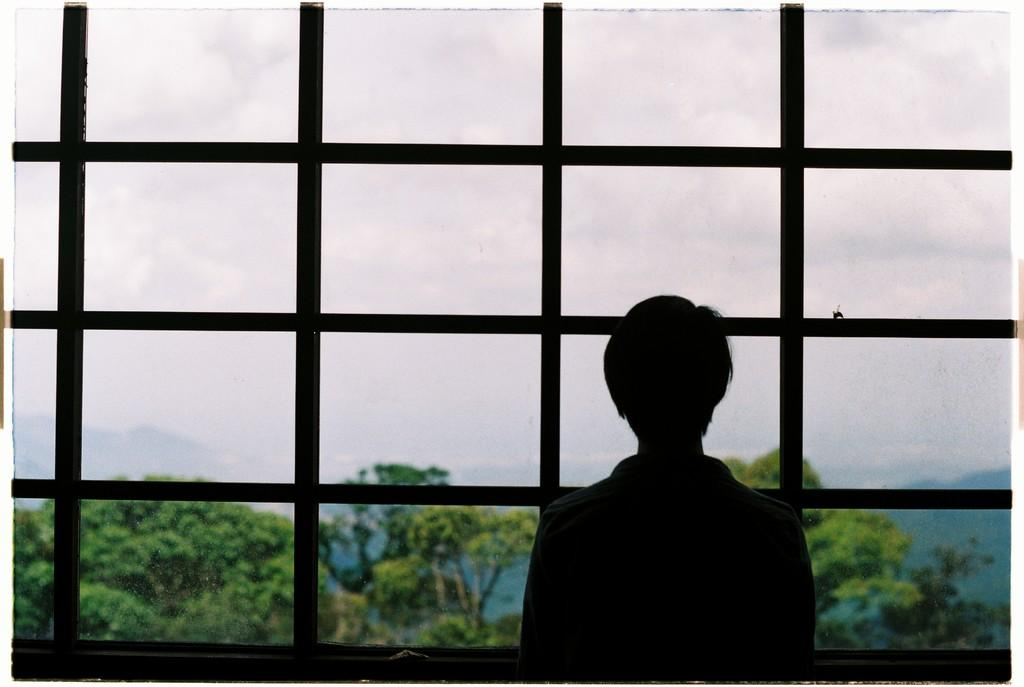What is the person in the image doing? The person is standing and watching outside through a window. What can be seen on the other side of the window? Trees and mountains are visible on the other side of the window. What type of committee is meeting in the image? There is no committee meeting in the image; it features a person watching outside through a window. Can you tell me the credit score of the person in the image? There is no information about the person's credit score in the image. 